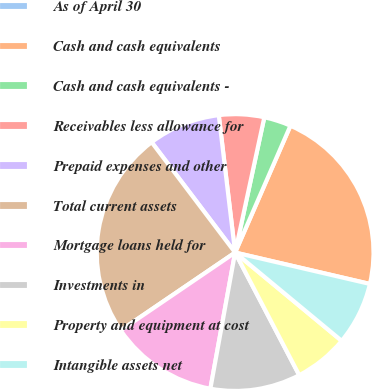Convert chart to OTSL. <chart><loc_0><loc_0><loc_500><loc_500><pie_chart><fcel>As of April 30<fcel>Cash and cash equivalents<fcel>Cash and cash equivalents -<fcel>Receivables less allowance for<fcel>Prepaid expenses and other<fcel>Total current assets<fcel>Mortgage loans held for<fcel>Investments in<fcel>Property and equipment at cost<fcel>Intangible assets net<nl><fcel>0.0%<fcel>22.1%<fcel>3.16%<fcel>5.27%<fcel>8.42%<fcel>24.2%<fcel>12.63%<fcel>10.53%<fcel>6.32%<fcel>7.37%<nl></chart> 